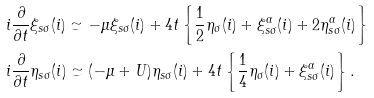<formula> <loc_0><loc_0><loc_500><loc_500>& i \frac { \partial } { \partial t } \xi _ { s \sigma } ( i ) \simeq - \mu \xi _ { s \sigma } ( i ) + 4 t \left \{ \frac { 1 } { 2 } \eta _ { \sigma } ( i ) + \xi ^ { \alpha } _ { s \sigma } ( i ) + 2 \eta ^ { \alpha } _ { s \sigma } ( i ) \right \} \\ & i \frac { \partial } { \partial t } \eta _ { s \sigma } ( i ) \simeq ( - \mu + U ) \eta _ { s \sigma } ( i ) + 4 t \left \{ \frac { 1 } { 4 } \eta _ { \sigma } ( i ) + \xi ^ { \alpha } _ { s \sigma } ( i ) \right \} .</formula> 